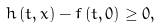Convert formula to latex. <formula><loc_0><loc_0><loc_500><loc_500>h \left ( t , x \right ) - f \left ( t , 0 \right ) \geq 0 ,</formula> 